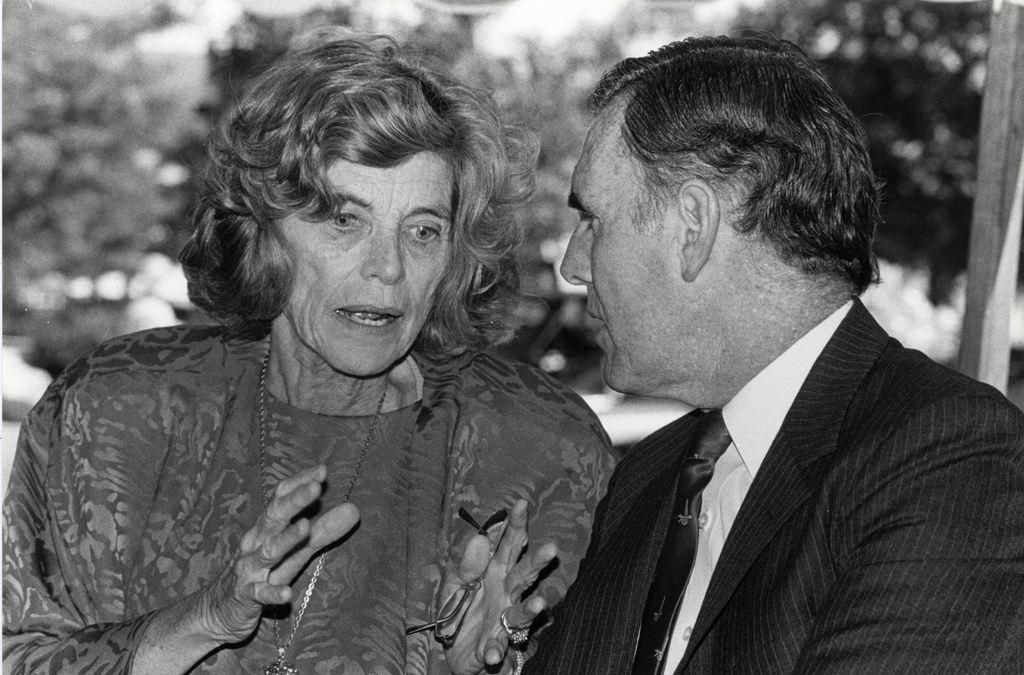How would you summarize this image in a sentence or two? This is a black and white image. On the left side, there is a woman, holding a spectacle with a hand and speaking. On the right side, there is a person in a suit. In the background, there are trees. And the background is blurred. 